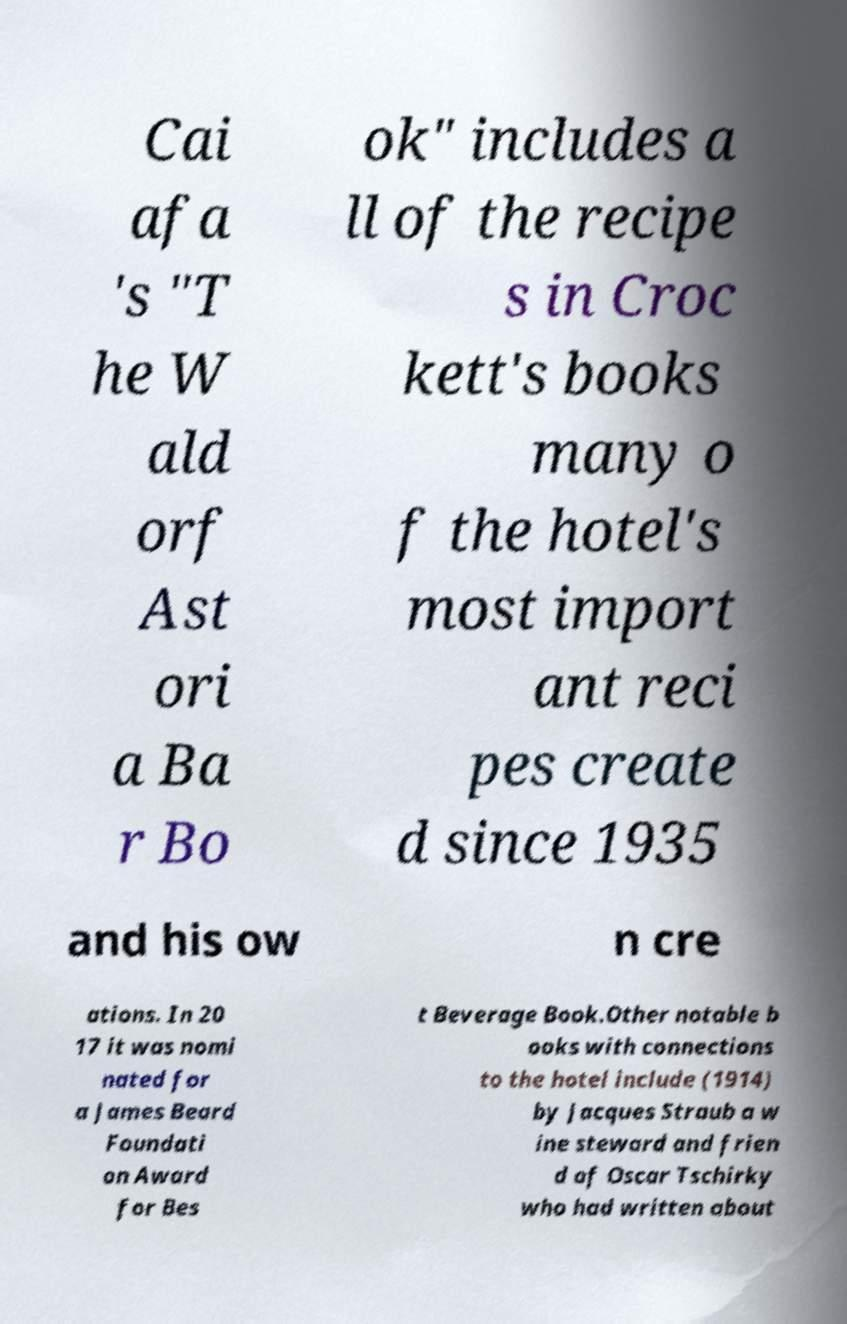What messages or text are displayed in this image? I need them in a readable, typed format. Cai afa 's "T he W ald orf Ast ori a Ba r Bo ok" includes a ll of the recipe s in Croc kett's books many o f the hotel's most import ant reci pes create d since 1935 and his ow n cre ations. In 20 17 it was nomi nated for a James Beard Foundati on Award for Bes t Beverage Book.Other notable b ooks with connections to the hotel include (1914) by Jacques Straub a w ine steward and frien d of Oscar Tschirky who had written about 